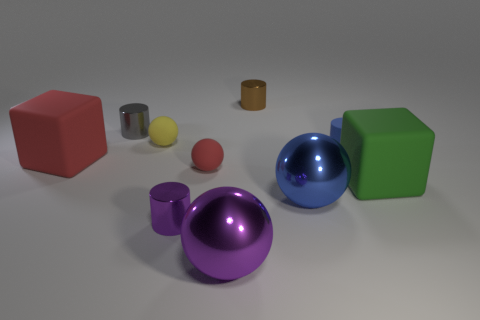There is a sphere that is behind the blue matte thing; does it have the same size as the brown metal cylinder?
Offer a very short reply. Yes. Is there any other thing that is the same size as the gray cylinder?
Give a very brief answer. Yes. What is the size of the blue object that is the same shape as the tiny purple thing?
Ensure brevity in your answer.  Small. Are there an equal number of tiny purple metallic objects in front of the purple metal cylinder and large cubes that are left of the tiny brown metallic cylinder?
Your response must be concise. No. What size is the block that is on the left side of the purple sphere?
Provide a short and direct response. Large. Is there any other thing that is the same shape as the brown object?
Offer a very short reply. Yes. What material is the large object that is the same color as the tiny matte cylinder?
Offer a terse response. Metal. Are there the same number of matte objects behind the blue sphere and small green rubber blocks?
Your answer should be very brief. No. There is a large blue shiny object; are there any big blue balls in front of it?
Offer a terse response. No. There is a large blue thing; does it have the same shape as the red object that is to the right of the small yellow matte ball?
Ensure brevity in your answer.  Yes. 